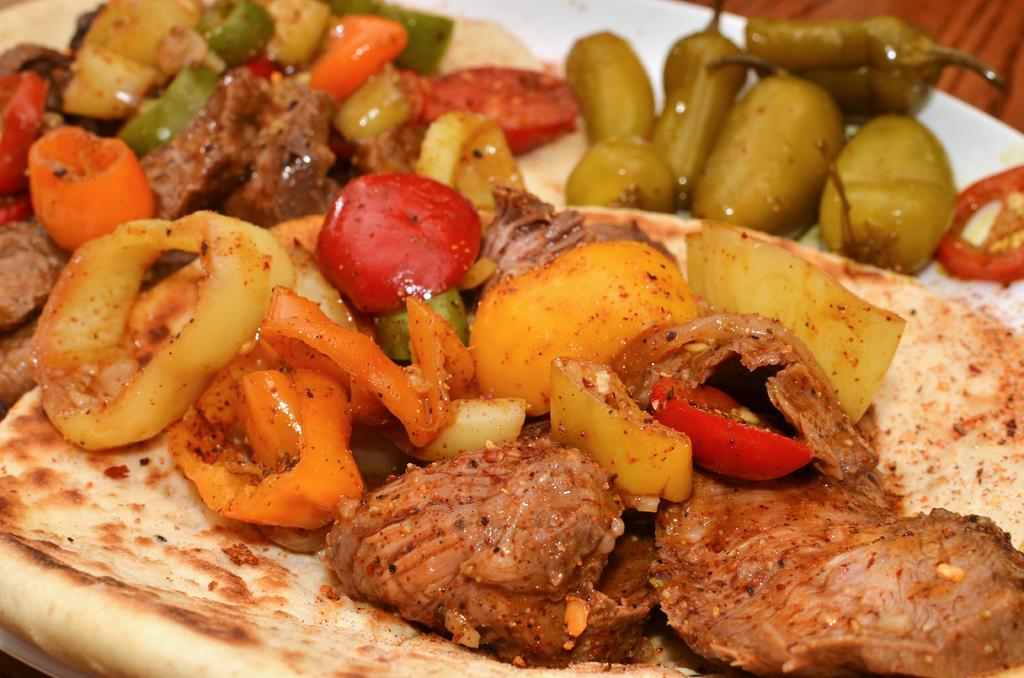What type of food item is present in the image? There is a food item in the image. What ingredients can be found in the food item? The food item contains tomatoes, chilies, and chicken. What hobbies does the food item have in the image? The food item does not have any hobbies, as it is an inanimate object and cannot engage in hobbies. 